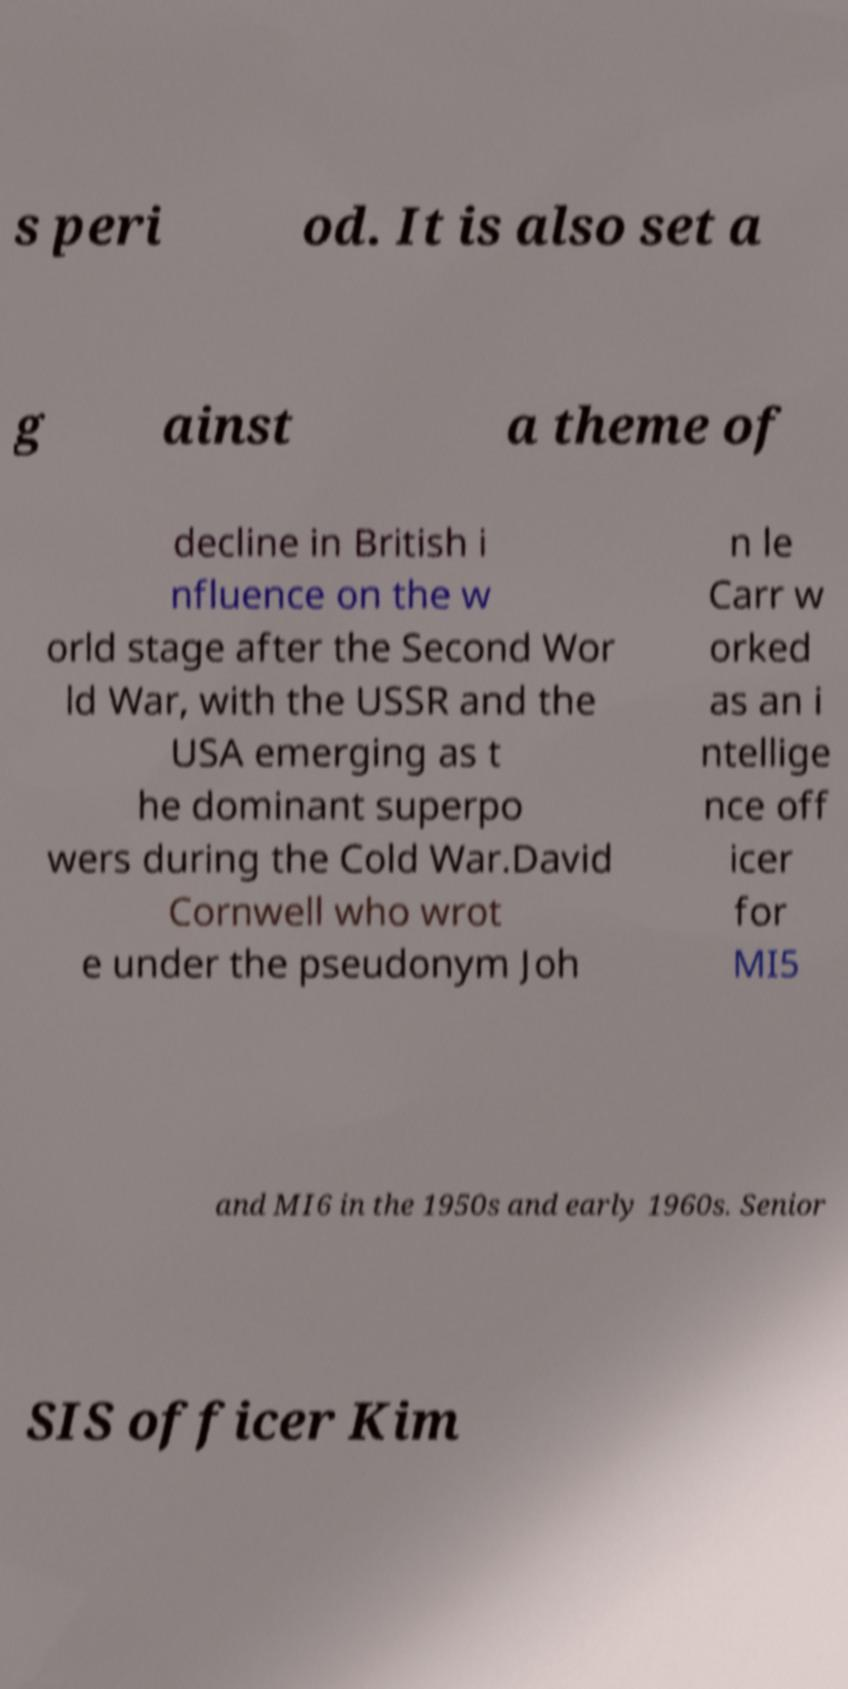What messages or text are displayed in this image? I need them in a readable, typed format. s peri od. It is also set a g ainst a theme of decline in British i nfluence on the w orld stage after the Second Wor ld War, with the USSR and the USA emerging as t he dominant superpo wers during the Cold War.David Cornwell who wrot e under the pseudonym Joh n le Carr w orked as an i ntellige nce off icer for MI5 and MI6 in the 1950s and early 1960s. Senior SIS officer Kim 